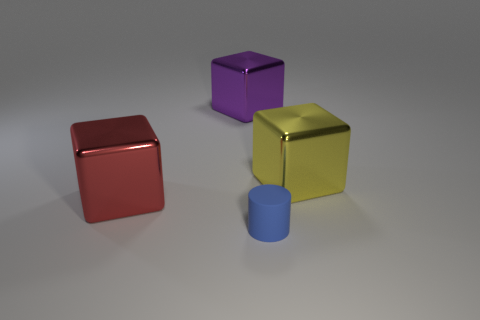Add 4 cylinders. How many objects exist? 8 Subtract 1 blocks. How many blocks are left? 2 Subtract all gray cylinders. Subtract all yellow balls. How many cylinders are left? 1 Subtract all gray cylinders. How many yellow blocks are left? 1 Subtract all large yellow cubes. Subtract all purple things. How many objects are left? 2 Add 2 yellow objects. How many yellow objects are left? 3 Add 3 big purple shiny objects. How many big purple shiny objects exist? 4 Subtract 0 yellow cylinders. How many objects are left? 4 Subtract all blocks. How many objects are left? 1 